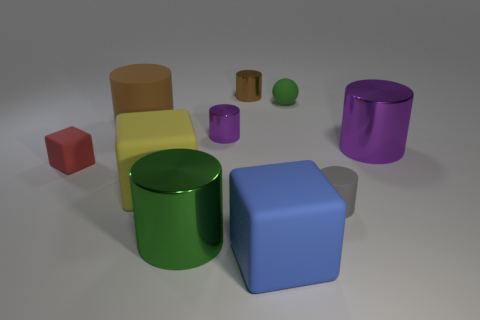How many shiny blocks are the same color as the tiny rubber ball?
Make the answer very short. 0. Is the big purple shiny object the same shape as the red rubber thing?
Make the answer very short. No. Are there any other things that are the same size as the gray object?
Offer a very short reply. Yes. What size is the yellow object that is the same shape as the big blue rubber thing?
Ensure brevity in your answer.  Large. Are there more purple objects in front of the large purple cylinder than metallic objects in front of the big brown rubber cylinder?
Keep it short and to the point. No. Are the small cube and the green object that is on the right side of the blue block made of the same material?
Provide a succinct answer. Yes. Is there any other thing that is the same shape as the tiny brown metal thing?
Your response must be concise. Yes. What is the color of the big cylinder that is left of the small rubber cylinder and behind the tiny red block?
Give a very brief answer. Brown. The small shiny thing in front of the big brown rubber thing has what shape?
Ensure brevity in your answer.  Cylinder. What is the size of the matte object that is in front of the shiny object in front of the large metal cylinder that is behind the red matte block?
Your response must be concise. Large. 